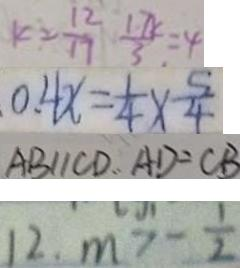<formula> <loc_0><loc_0><loc_500><loc_500>K 2 = \frac { 1 2 } { 1 7 } \frac { 1 7 K } { 3 } = 4 
 0 . 4 x = \frac { 1 } { 4 } \times \frac { 5 } { 4 } 
 A B / / C D . . A D = C B 
 1 2 . m > - \frac { 1 } { 2 }</formula> 